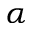Convert formula to latex. <formula><loc_0><loc_0><loc_500><loc_500>\alpha</formula> 